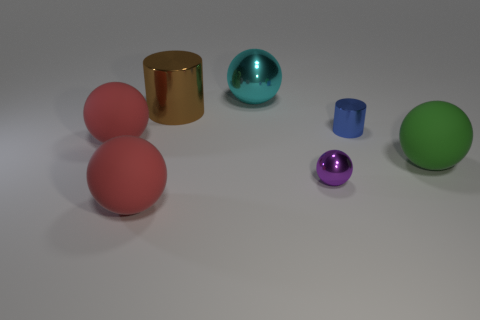Subtract all tiny balls. How many balls are left? 4 Add 3 small gray rubber things. How many objects exist? 10 Subtract all brown cubes. How many red balls are left? 2 Subtract 5 balls. How many balls are left? 0 Subtract all yellow spheres. Subtract all brown cylinders. How many spheres are left? 5 Subtract all big cylinders. Subtract all big cyan cylinders. How many objects are left? 6 Add 6 blue metallic cylinders. How many blue metallic cylinders are left? 7 Add 3 tiny brown rubber things. How many tiny brown rubber things exist? 3 Subtract all brown cylinders. How many cylinders are left? 1 Subtract 1 green balls. How many objects are left? 6 